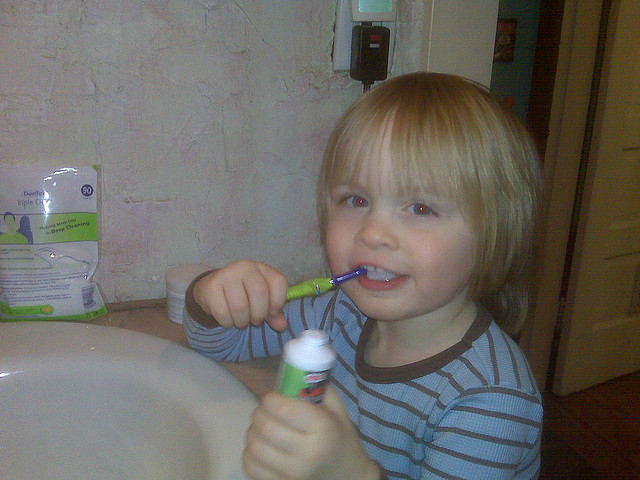<image>What character is on the babies brush? It's unclear what character is on the baby's brush. It could be Buzz Lightyear, Ninja Turtles, a dog, Barney, or Thomas. However, it's also possible that there is no character or it's not visible. What character is on the babies brush? I am not aware of what character is on the babies brush. It is not possible to determine from the given information. 